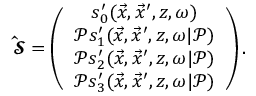<formula> <loc_0><loc_0><loc_500><loc_500>\begin{array} { r } { { \widehat { \mathbf c a l { S } } } = \left ( \begin{array} { c } { s _ { 0 } ^ { \prime } ( \vec { x } , \vec { x } ^ { \prime } , z , \omega ) } \\ { \mathcal { P } s _ { 1 } ^ { \prime } ( \vec { x } , \vec { x } ^ { \prime } , z , \omega | \mathcal { P } ) } \\ { \mathcal { P } s _ { 2 } ^ { \prime } ( \vec { x } , \vec { x } ^ { \prime } , z , \omega | \mathcal { P } ) } \\ { \mathcal { P } s _ { 3 } ^ { \prime } ( \vec { x } , \vec { x } ^ { \prime } , z , \omega | \mathcal { P } ) } \end{array} \right ) . } \end{array}</formula> 